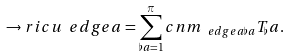Convert formula to latex. <formula><loc_0><loc_0><loc_500><loc_500>\to r i c u _ { \ } e d g e a = \sum _ { \flat a = 1 } ^ { \pi } c n m _ { \ e d g e a \flat a } T _ { \flat } a .</formula> 